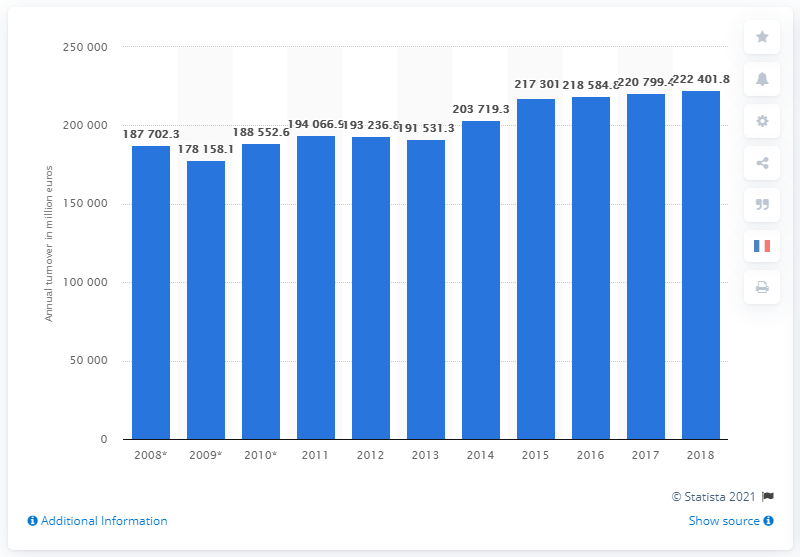Identify some key points in this picture. According to data from the EU in 2018, the turnover of clothing stores was 22,240.18 million euros. 